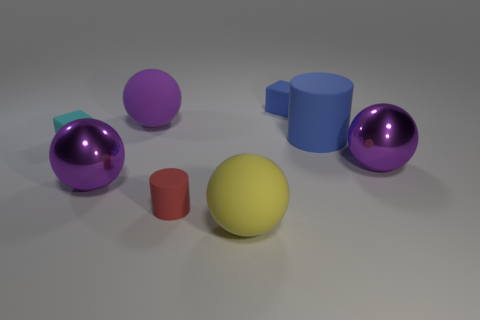Subtract all red cylinders. How many purple balls are left? 3 Subtract 1 balls. How many balls are left? 3 Subtract all green cubes. Subtract all yellow cylinders. How many cubes are left? 2 Add 1 yellow rubber objects. How many objects exist? 9 Subtract all blocks. How many objects are left? 6 Add 3 tiny red rubber blocks. How many tiny red rubber blocks exist? 3 Subtract 0 gray cylinders. How many objects are left? 8 Subtract all large yellow rubber things. Subtract all cyan objects. How many objects are left? 6 Add 5 cyan objects. How many cyan objects are left? 6 